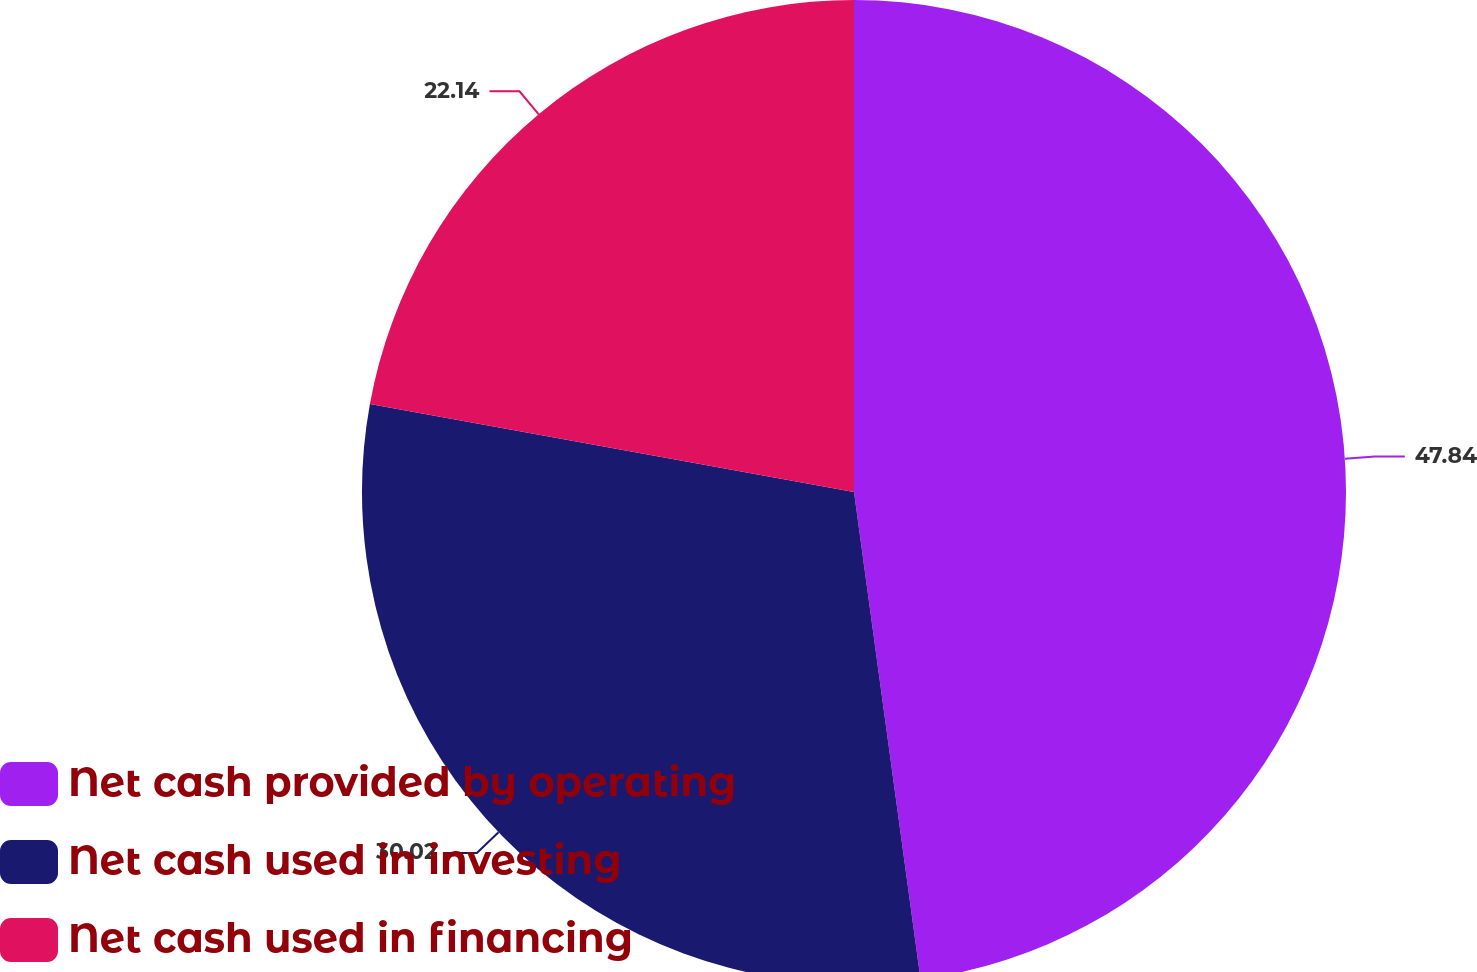Convert chart to OTSL. <chart><loc_0><loc_0><loc_500><loc_500><pie_chart><fcel>Net cash provided by operating<fcel>Net cash used in investing<fcel>Net cash used in financing<nl><fcel>47.84%<fcel>30.02%<fcel>22.14%<nl></chart> 